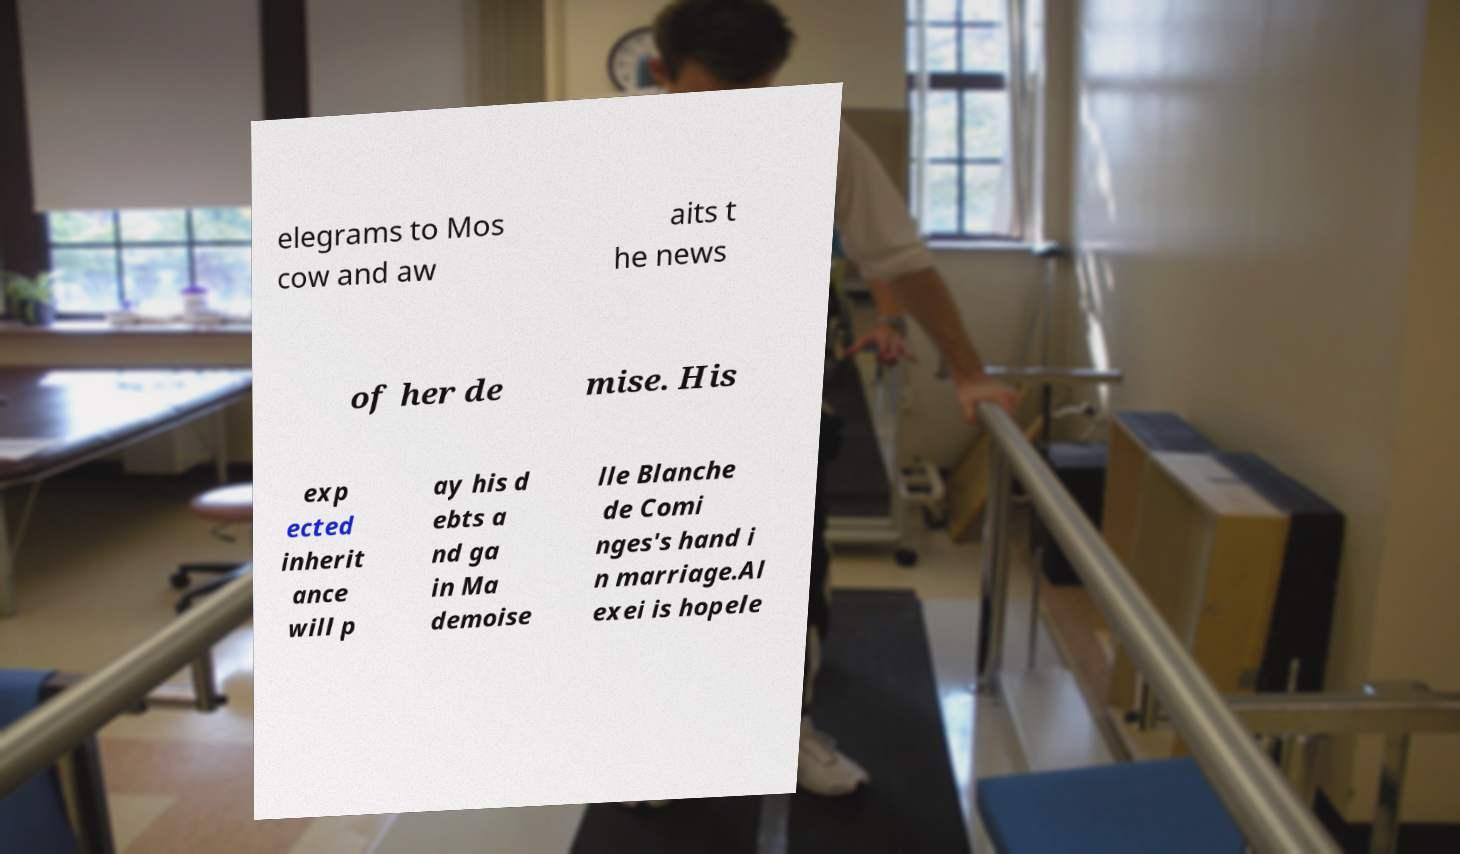Please identify and transcribe the text found in this image. elegrams to Mos cow and aw aits t he news of her de mise. His exp ected inherit ance will p ay his d ebts a nd ga in Ma demoise lle Blanche de Comi nges's hand i n marriage.Al exei is hopele 